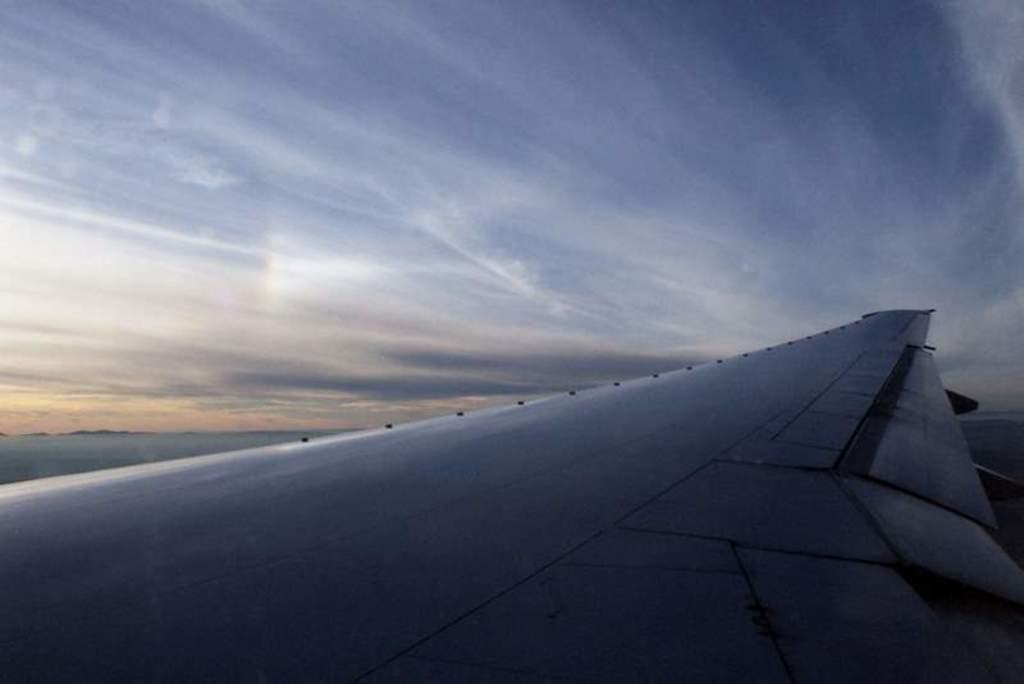What can be seen at the top of the image? The sky is visible towards the top of the image. What is located towards the bottom of the image? There is an airplane wing towards the bottom of the image. What color is the crayon used to draw the airplane wing in the image? There is no crayon or drawing present in the image; it is a photograph of an actual airplane wing. How many pens are visible in the image? There are no pens visible in the image. 